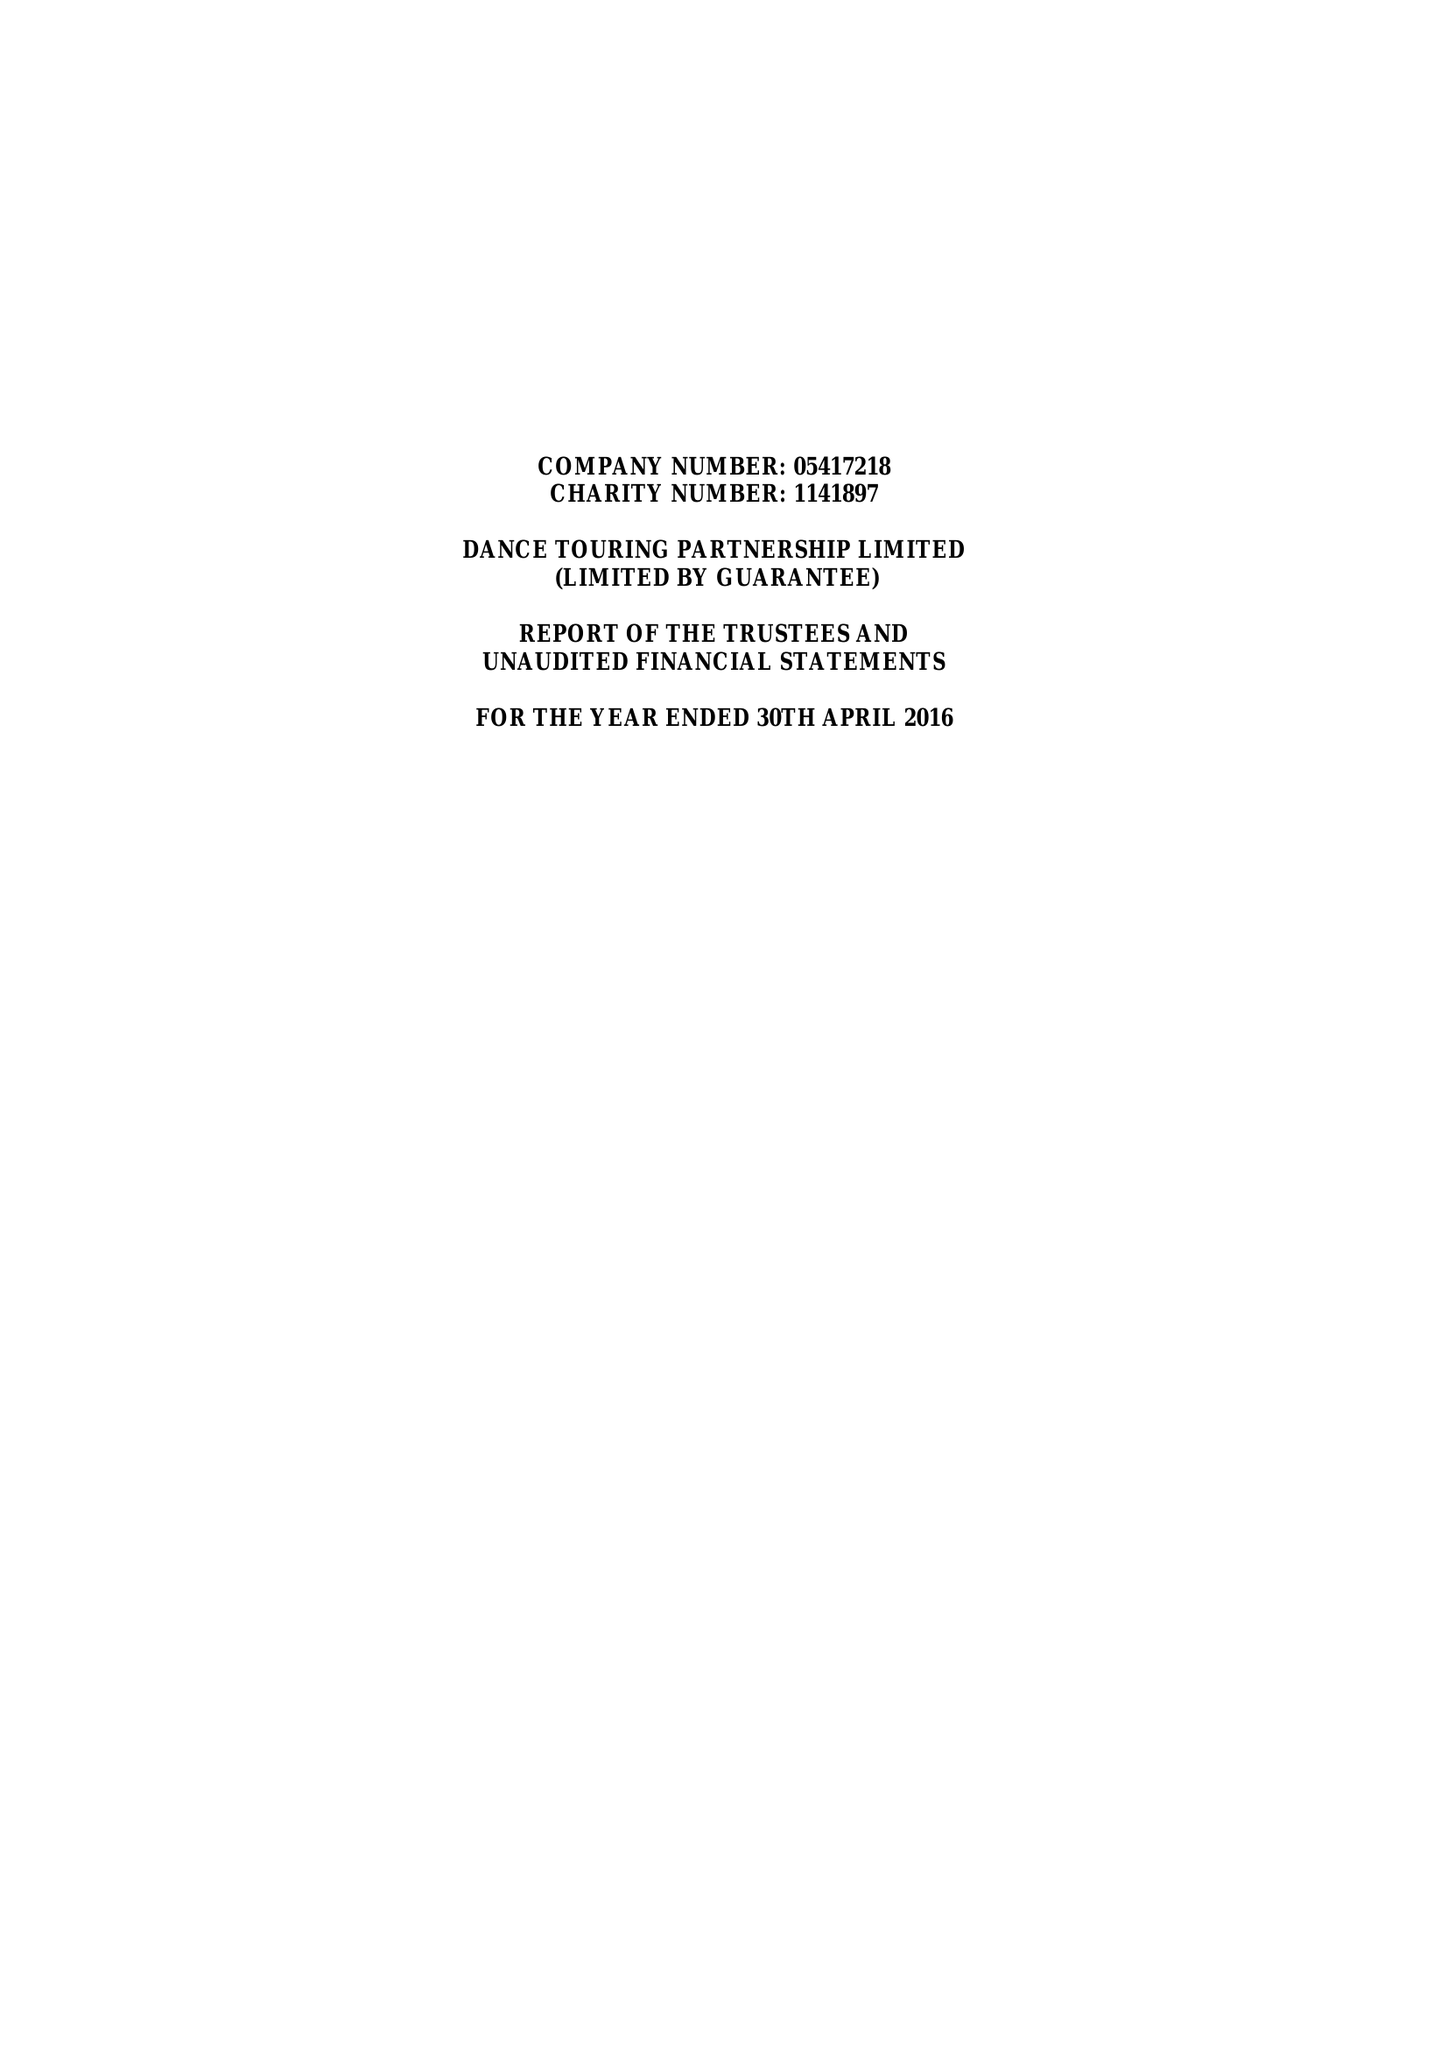What is the value for the spending_annually_in_british_pounds?
Answer the question using a single word or phrase. 75032.00 